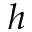<formula> <loc_0><loc_0><loc_500><loc_500>h</formula> 